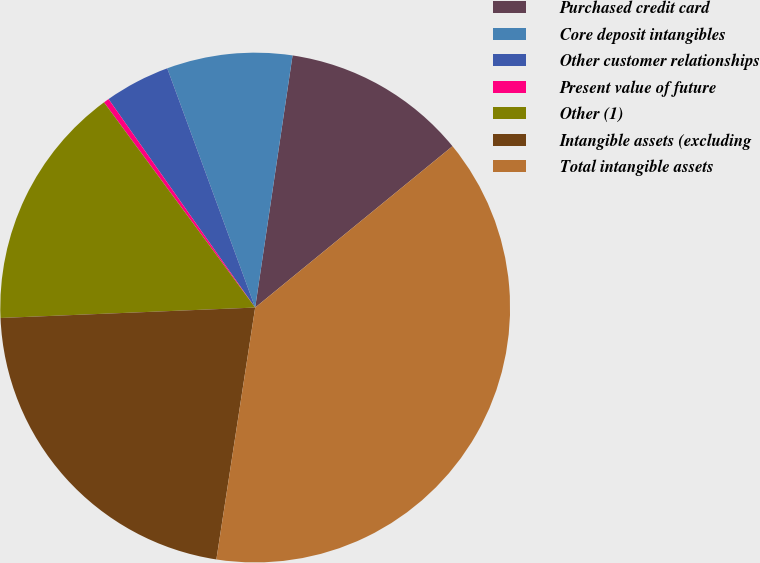Convert chart. <chart><loc_0><loc_0><loc_500><loc_500><pie_chart><fcel>Purchased credit card<fcel>Core deposit intangibles<fcel>Other customer relationships<fcel>Present value of future<fcel>Other (1)<fcel>Intangible assets (excluding<fcel>Total intangible assets<nl><fcel>11.75%<fcel>7.95%<fcel>4.15%<fcel>0.35%<fcel>15.55%<fcel>21.92%<fcel>38.35%<nl></chart> 